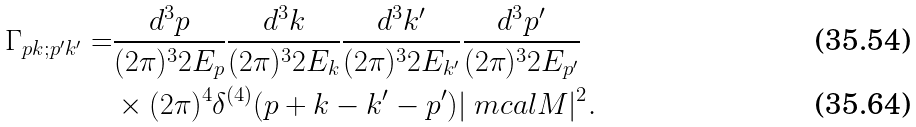<formula> <loc_0><loc_0><loc_500><loc_500>\Gamma _ { p k ; p ^ { \prime } k ^ { \prime } } = & \frac { d ^ { 3 } p } { ( 2 \pi ) ^ { 3 } 2 E _ { p } } \frac { d ^ { 3 } k } { ( 2 \pi ) ^ { 3 } 2 E _ { k } } \frac { d ^ { 3 } k ^ { \prime } } { ( 2 \pi ) ^ { 3 } 2 E _ { k ^ { \prime } } } \frac { d ^ { 3 } p ^ { \prime } } { ( 2 \pi ) ^ { 3 } 2 E _ { p ^ { \prime } } } \\ & \times ( 2 \pi ) ^ { 4 } \delta ^ { ( 4 ) } ( p + k - k ^ { \prime } - p ^ { \prime } ) | \ m c a l M | ^ { 2 } .</formula> 